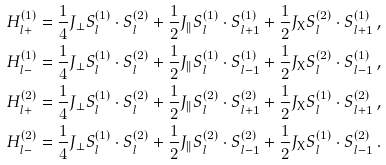<formula> <loc_0><loc_0><loc_500><loc_500>H _ { l + } ^ { ( 1 ) } & = { \frac { 1 } { 4 } } J _ { \bot } { S } _ { l } ^ { ( 1 ) } \cdot { S } _ { l } ^ { ( 2 ) } + { \frac { 1 } { 2 } } J _ { \| } { S } _ { l } ^ { ( 1 ) } \cdot { S } _ { l + 1 } ^ { ( 1 ) } + { \frac { 1 } { 2 } } J _ { \text {X} } { S } _ { l } ^ { ( 2 ) } \cdot { S } _ { l + 1 } ^ { ( 1 ) } \, , \\ H _ { l - } ^ { ( 1 ) } & = { \frac { 1 } { 4 } } J _ { \bot } { S } _ { l } ^ { ( 1 ) } \cdot { S } _ { l } ^ { ( 2 ) } + { \frac { 1 } { 2 } } J _ { \| } { S } _ { l } ^ { ( 1 ) } \cdot { S } _ { l - 1 } ^ { ( 1 ) } + { \frac { 1 } { 2 } } J _ { \text {X} } { S } _ { l } ^ { ( 2 ) } \cdot { S } _ { l - 1 } ^ { ( 1 ) } \, , \\ H _ { l + } ^ { ( 2 ) } & = { \frac { 1 } { 4 } } J _ { \bot } { S } _ { l } ^ { ( 1 ) } \cdot { S } _ { l } ^ { ( 2 ) } + { \frac { 1 } { 2 } } J _ { \| } { S } _ { l } ^ { ( 2 ) } \cdot { S } _ { l + 1 } ^ { ( 2 ) } + { \frac { 1 } { 2 } } J _ { \text {X} } { S } _ { l } ^ { ( 1 ) } \cdot { S } _ { l + 1 } ^ { ( 2 ) } \, , \\ H _ { l - } ^ { ( 2 ) } & = { \frac { 1 } { 4 } } J _ { \bot } { S } _ { l } ^ { ( 1 ) } \cdot { S } _ { l } ^ { ( 2 ) } + { \frac { 1 } { 2 } } J _ { \| } { S } _ { l } ^ { ( 2 ) } \cdot { S } _ { l - 1 } ^ { ( 2 ) } + { \frac { 1 } { 2 } } J _ { \text {X} } { S } _ { l } ^ { ( 1 ) } \cdot { S } _ { l - 1 } ^ { ( 2 ) } \, .</formula> 